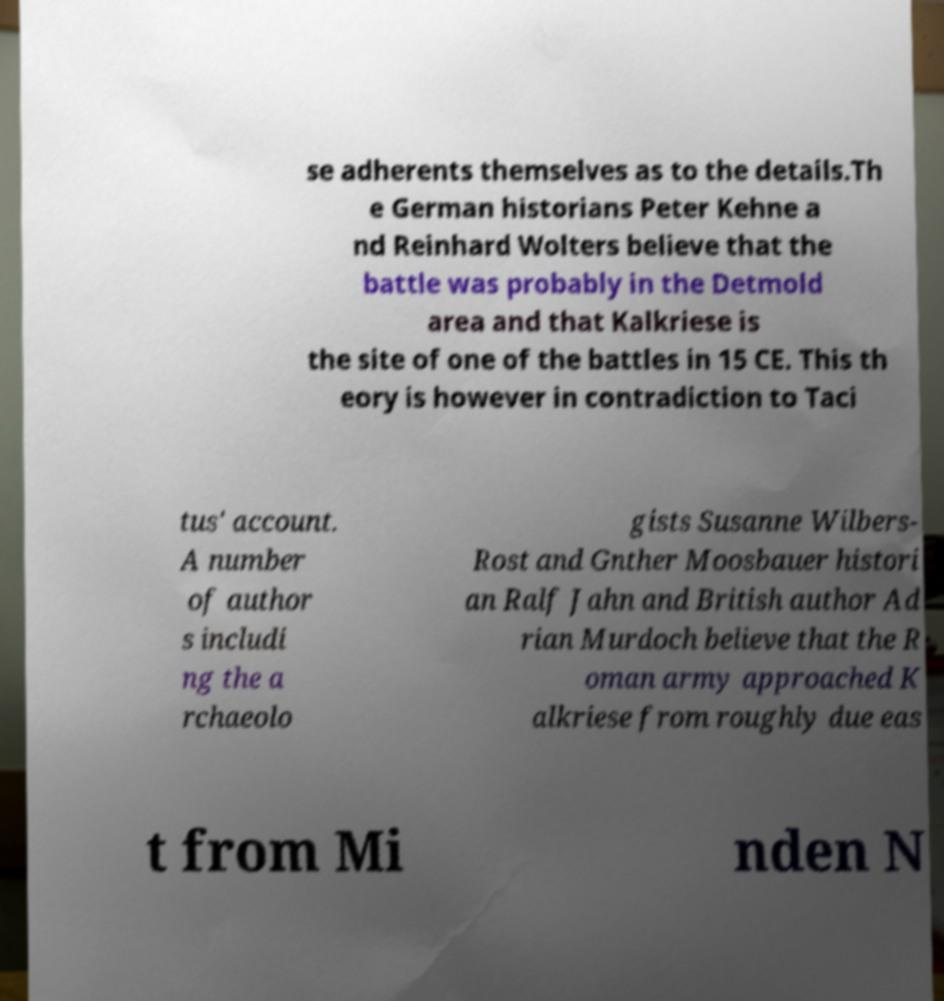Please read and relay the text visible in this image. What does it say? se adherents themselves as to the details.Th e German historians Peter Kehne a nd Reinhard Wolters believe that the battle was probably in the Detmold area and that Kalkriese is the site of one of the battles in 15 CE. This th eory is however in contradiction to Taci tus' account. A number of author s includi ng the a rchaeolo gists Susanne Wilbers- Rost and Gnther Moosbauer histori an Ralf Jahn and British author Ad rian Murdoch believe that the R oman army approached K alkriese from roughly due eas t from Mi nden N 